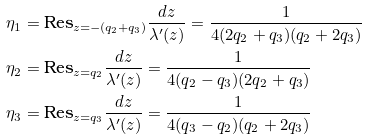<formula> <loc_0><loc_0><loc_500><loc_500>\eta _ { 1 } & = \text {Res} _ { z = - ( q _ { 2 } + q _ { 3 } ) } \frac { d z } { \lambda ^ { \prime } ( z ) } = \frac { 1 } { 4 ( 2 q _ { 2 } + q _ { 3 } ) ( q _ { 2 } + 2 q _ { 3 } ) } \\ \eta _ { 2 } & = \text {Res} _ { z = q _ { 2 } } \frac { d z } { \lambda ^ { \prime } ( z ) } = \frac { 1 } { 4 ( q _ { 2 } - q _ { 3 } ) ( 2 q _ { 2 } + q _ { 3 } ) } \\ \eta _ { 3 } & = \text {Res} _ { z = q _ { 3 } } \frac { d z } { \lambda ^ { \prime } ( z ) } = \frac { 1 } { 4 ( q _ { 3 } - q _ { 2 } ) ( q _ { 2 } + 2 q _ { 3 } ) }</formula> 